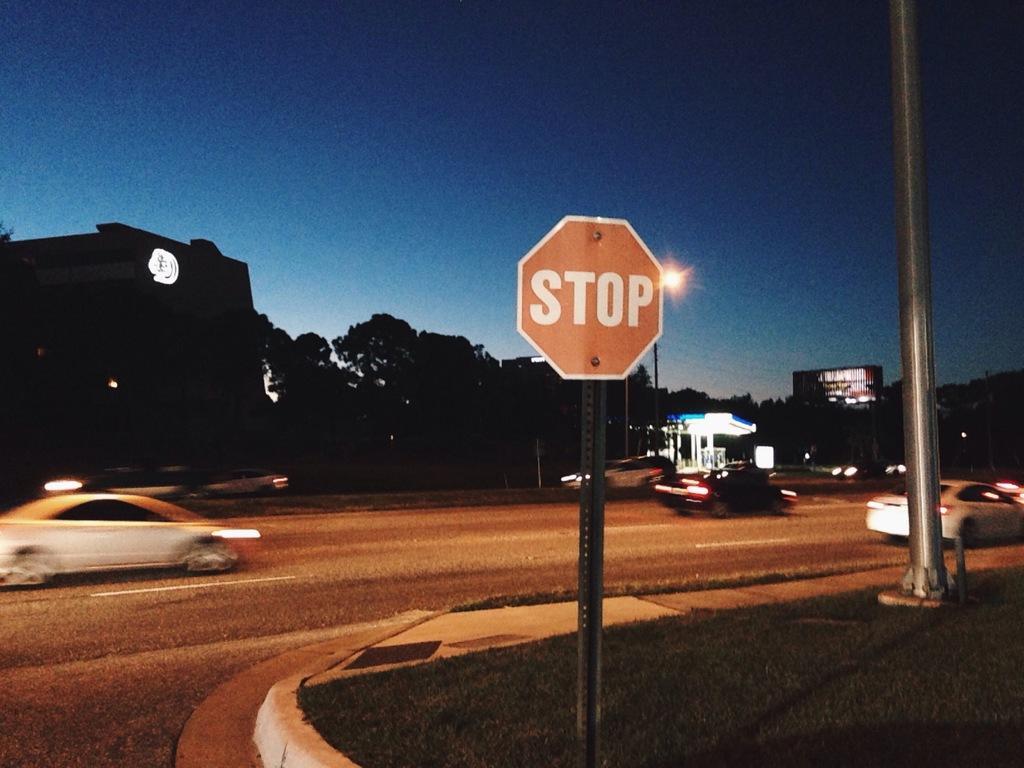Can you describe this image briefly? In this picture, we can see a few vehicles, road, ground with grass, poles, lights, buildings, posters, sign board, shed, and we can see the sky. 